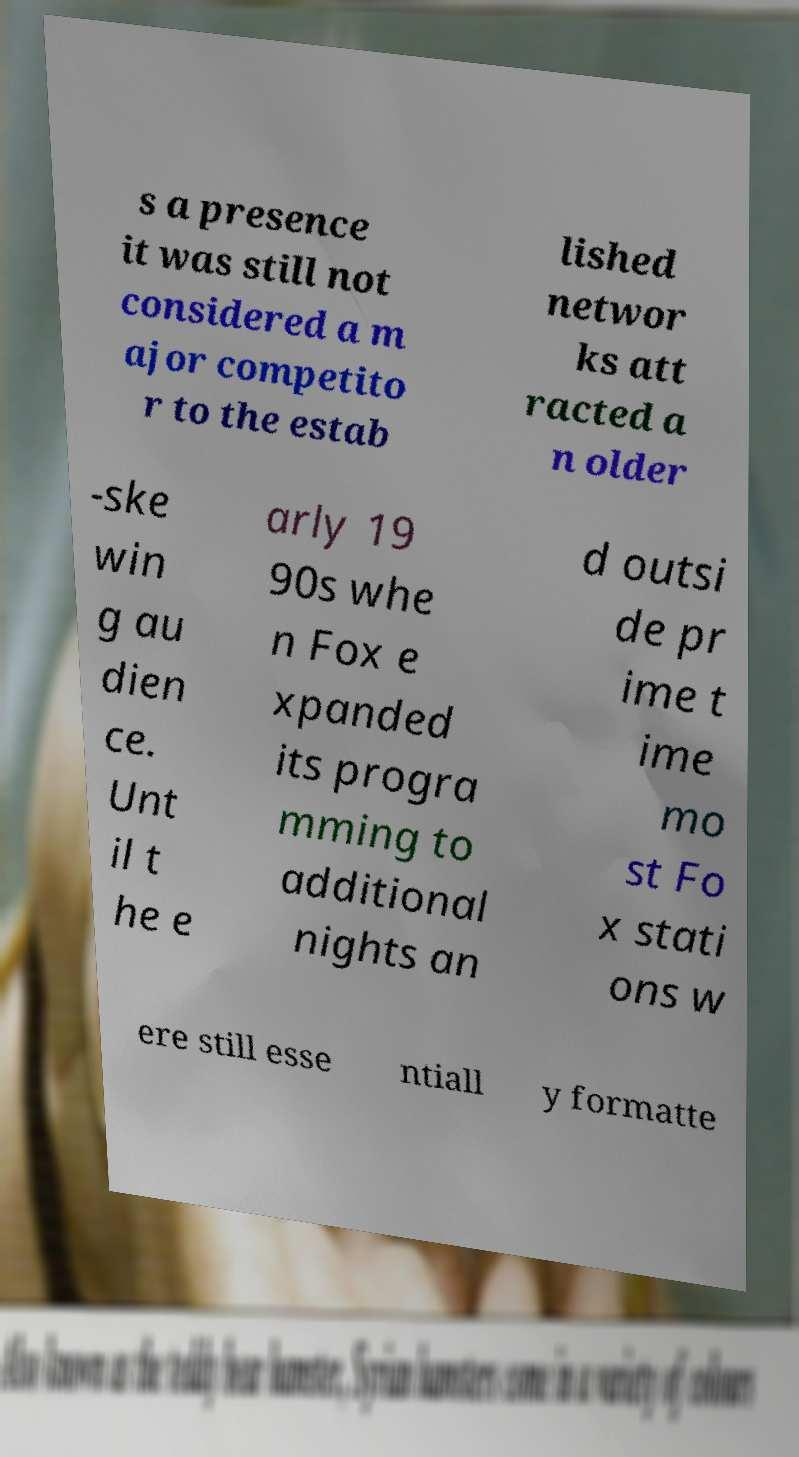I need the written content from this picture converted into text. Can you do that? s a presence it was still not considered a m ajor competito r to the estab lished networ ks att racted a n older -ske win g au dien ce. Unt il t he e arly 19 90s whe n Fox e xpanded its progra mming to additional nights an d outsi de pr ime t ime mo st Fo x stati ons w ere still esse ntiall y formatte 